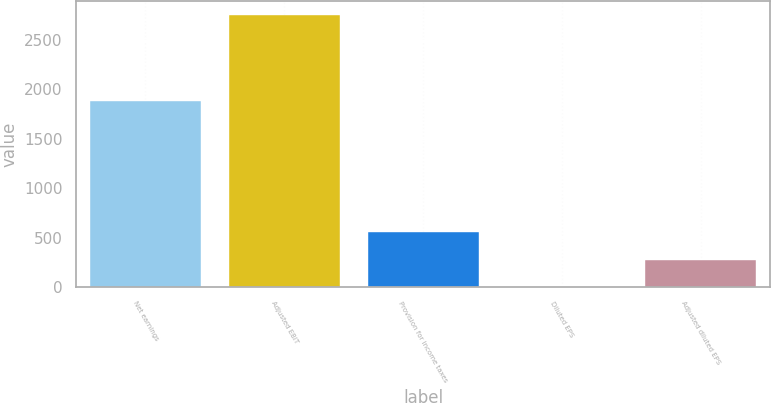Convert chart. <chart><loc_0><loc_0><loc_500><loc_500><bar_chart><fcel>Net earnings<fcel>Adjusted EBIT<fcel>Provision for income taxes<fcel>Diluted EPS<fcel>Adjusted diluted EPS<nl><fcel>1884.9<fcel>2754.6<fcel>554.33<fcel>4.25<fcel>279.29<nl></chart> 